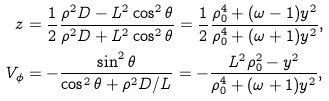<formula> <loc_0><loc_0><loc_500><loc_500>z & = \frac { 1 } { 2 } \frac { \rho ^ { 2 } D - L ^ { 2 } \cos ^ { 2 } \theta } { \rho ^ { 2 } D + L ^ { 2 } \cos ^ { 2 } \theta } = \frac { 1 } { 2 } \frac { \rho _ { 0 } ^ { 4 } + ( \omega - 1 ) y ^ { 2 } } { \rho _ { 0 } ^ { 4 } + ( \omega + 1 ) y ^ { 2 } } , \\ V _ { \phi } & = - \frac { \sin ^ { 2 } \theta } { \cos ^ { 2 } \theta + \rho ^ { 2 } D / L } = - \frac { L ^ { 2 } \rho _ { 0 } ^ { 2 } - y ^ { 2 } } { \rho _ { 0 } ^ { 4 } + ( \omega + 1 ) y ^ { 2 } } ,</formula> 